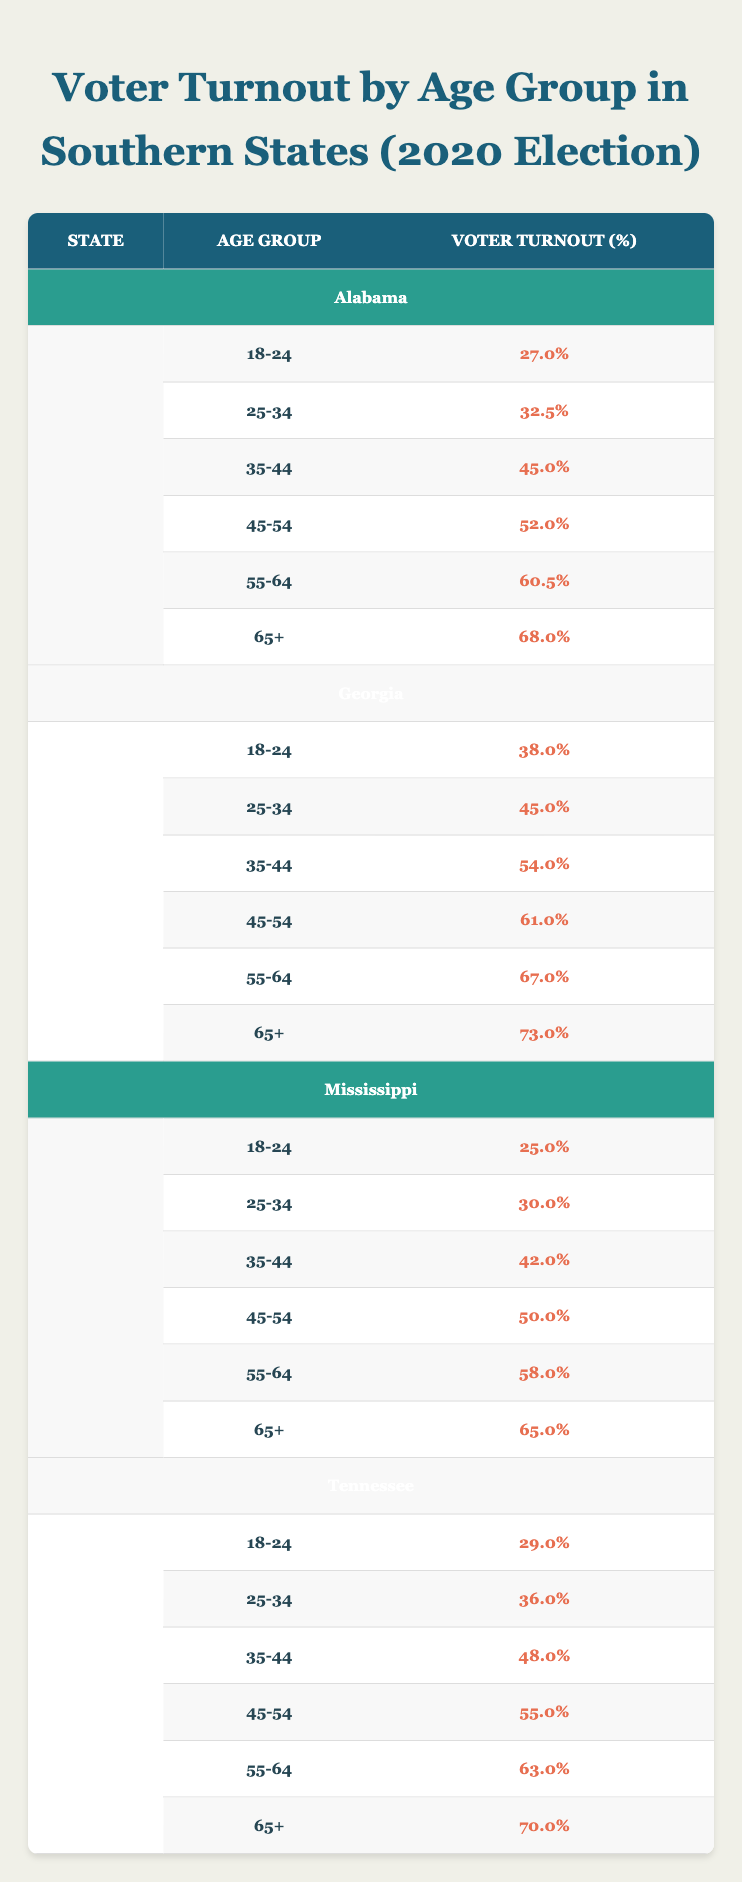What is the voter turnout percentage for the age group 65+ in Georgia? The table shows the voter turnout for each age group by state. For Georgia, the voter turnout for the age group 65+ is listed as 73.0%.
Answer: 73.0% Which state has the highest voter turnout for the age group 55-64? By comparing the turnout percentages for the age group 55-64 across the states, we see Alabama has 60.5%, Georgia has 67.0%, Mississippi has 58.0%, and Tennessee has 63.0%. Among these, Georgia has the highest at 67.0%.
Answer: Georgia What is the average voter turnout for the age group 18-24 across all listed Southern states? The percentages for the age group 18-24 are 27.0% in Alabama, 38.0% in Georgia, 25.0% in Mississippi, and 29.0% in Tennessee. We sum these values (27.0 + 38.0 + 25.0 + 29.0) which equals 119.0. There are 4 states, so we divide by 4 to find the average: 119.0 / 4 = 29.75%.
Answer: 29.75% Did more voters in the age group 45-54 in Georgia turn out than those in Alabama? The voter turnout for the age group 45-54 in Georgia is 61.0%, and in Alabama, it is 52.0%. Since 61.0% is greater than 52.0%, the statement is true.
Answer: Yes Which age group has the lowest voter turnout in Mississippi? Looking at the table, the lowest voter turnout in Mississippi is for the age group 18-24, which is 25.0%.
Answer: 18-24 